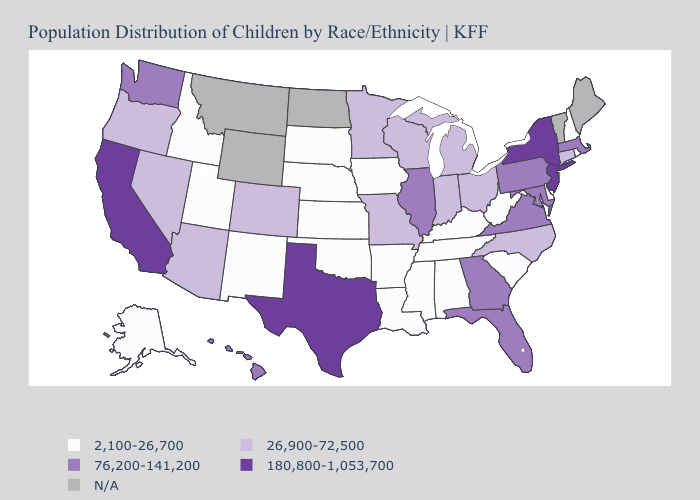Name the states that have a value in the range N/A?
Give a very brief answer. Maine, Montana, North Dakota, Vermont, Wyoming. What is the highest value in the Northeast ?
Quick response, please. 180,800-1,053,700. Does the first symbol in the legend represent the smallest category?
Be succinct. Yes. Which states have the lowest value in the USA?
Concise answer only. Alabama, Alaska, Arkansas, Delaware, Idaho, Iowa, Kansas, Kentucky, Louisiana, Mississippi, Nebraska, New Hampshire, New Mexico, Oklahoma, Rhode Island, South Carolina, South Dakota, Tennessee, Utah, West Virginia. Does New Jersey have the highest value in the USA?
Give a very brief answer. Yes. What is the value of West Virginia?
Short answer required. 2,100-26,700. Name the states that have a value in the range 26,900-72,500?
Answer briefly. Arizona, Colorado, Connecticut, Indiana, Michigan, Minnesota, Missouri, Nevada, North Carolina, Ohio, Oregon, Wisconsin. Does Pennsylvania have the highest value in the Northeast?
Be succinct. No. What is the value of Idaho?
Answer briefly. 2,100-26,700. Which states have the lowest value in the USA?
Give a very brief answer. Alabama, Alaska, Arkansas, Delaware, Idaho, Iowa, Kansas, Kentucky, Louisiana, Mississippi, Nebraska, New Hampshire, New Mexico, Oklahoma, Rhode Island, South Carolina, South Dakota, Tennessee, Utah, West Virginia. What is the value of Louisiana?
Keep it brief. 2,100-26,700. Which states have the lowest value in the MidWest?
Short answer required. Iowa, Kansas, Nebraska, South Dakota. Does Georgia have the lowest value in the USA?
Write a very short answer. No. Among the states that border South Dakota , which have the highest value?
Keep it brief. Minnesota. 